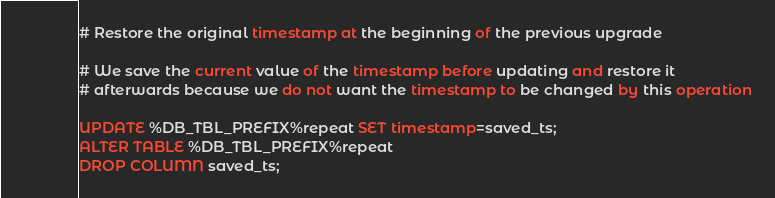Convert code to text. <code><loc_0><loc_0><loc_500><loc_500><_SQL_># Restore the original timestamp at the beginning of the previous upgrade

# We save the current value of the timestamp before updating and restore it 
# afterwards because we do not want the timestamp to be changed by this operation

UPDATE %DB_TBL_PREFIX%repeat SET timestamp=saved_ts;
ALTER TABLE %DB_TBL_PREFIX%repeat
DROP COLUMN saved_ts;
</code> 